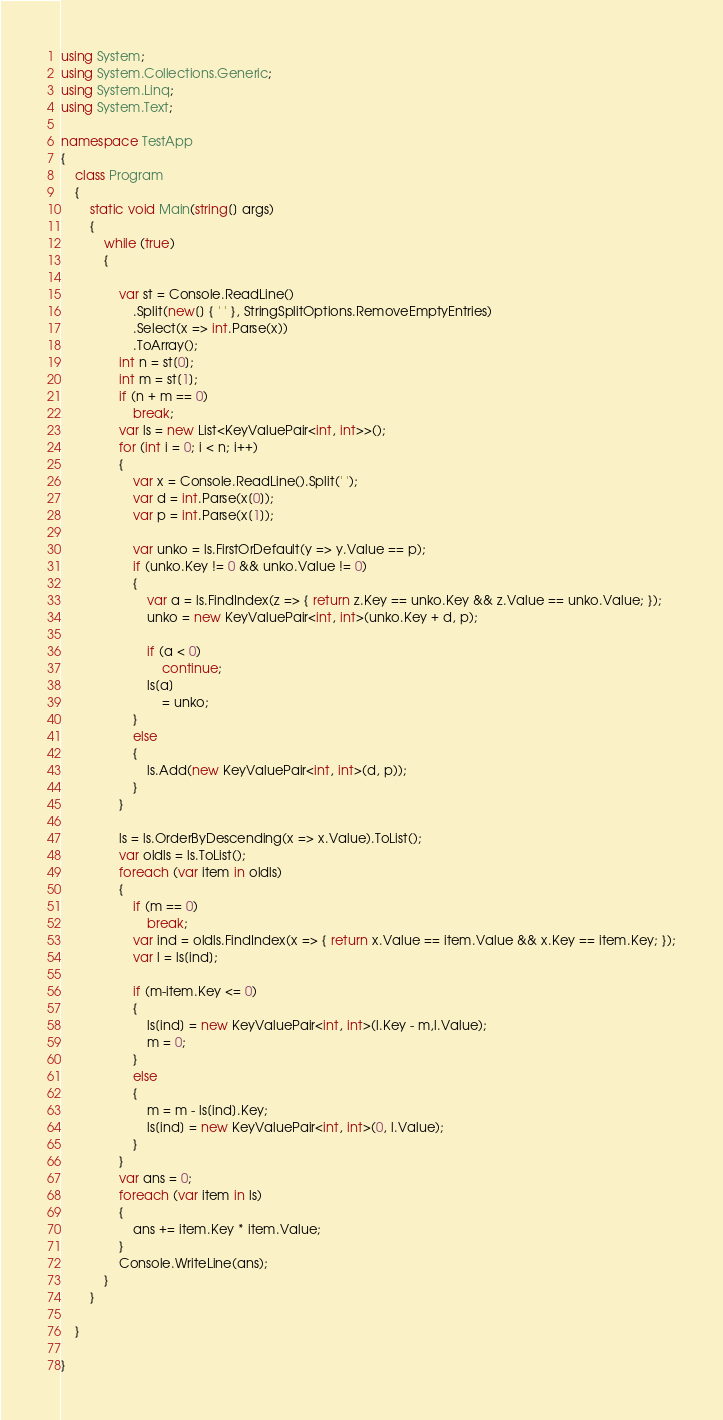<code> <loc_0><loc_0><loc_500><loc_500><_C#_>using System;
using System.Collections.Generic;
using System.Linq;
using System.Text;

namespace TestApp
{
    class Program
    {
        static void Main(string[] args)
        {
            while (true)
            {
                
                var st = Console.ReadLine()
                    .Split(new[] { ' ' }, StringSplitOptions.RemoveEmptyEntries)
                    .Select(x => int.Parse(x))
                    .ToArray();
                int n = st[0];
                int m = st[1];
                if (n + m == 0)
                    break;
                var ls = new List<KeyValuePair<int, int>>();
                for (int i = 0; i < n; i++)
                {
                    var x = Console.ReadLine().Split(' ');
                    var d = int.Parse(x[0]);
                    var p = int.Parse(x[1]);

                    var unko = ls.FirstOrDefault(y => y.Value == p);
                    if (unko.Key != 0 && unko.Value != 0)
                    {
                        var a = ls.FindIndex(z => { return z.Key == unko.Key && z.Value == unko.Value; });
                        unko = new KeyValuePair<int, int>(unko.Key + d, p);

                        if (a < 0)
                            continue;
                        ls[a]
                            = unko;
                    }
                    else
                    {
                        ls.Add(new KeyValuePair<int, int>(d, p));
                    }
                }
                
                ls = ls.OrderByDescending(x => x.Value).ToList();
                var oldls = ls.ToList();
                foreach (var item in oldls)
                {
                    if (m == 0)
                        break;
                    var ind = oldls.FindIndex(x => { return x.Value == item.Value && x.Key == item.Key; });
                    var l = ls[ind];

                    if (m-item.Key <= 0)
                    {
                        ls[ind] = new KeyValuePair<int, int>(l.Key - m,l.Value);
                        m = 0;
                    }
                    else
                    {
                        m = m - ls[ind].Key;
                        ls[ind] = new KeyValuePair<int, int>(0, l.Value);
                    }
                }
                var ans = 0;
                foreach (var item in ls)
                {
                    ans += item.Key * item.Value;
                }
                Console.WriteLine(ans);
            }
        }
        
    }

}
</code> 